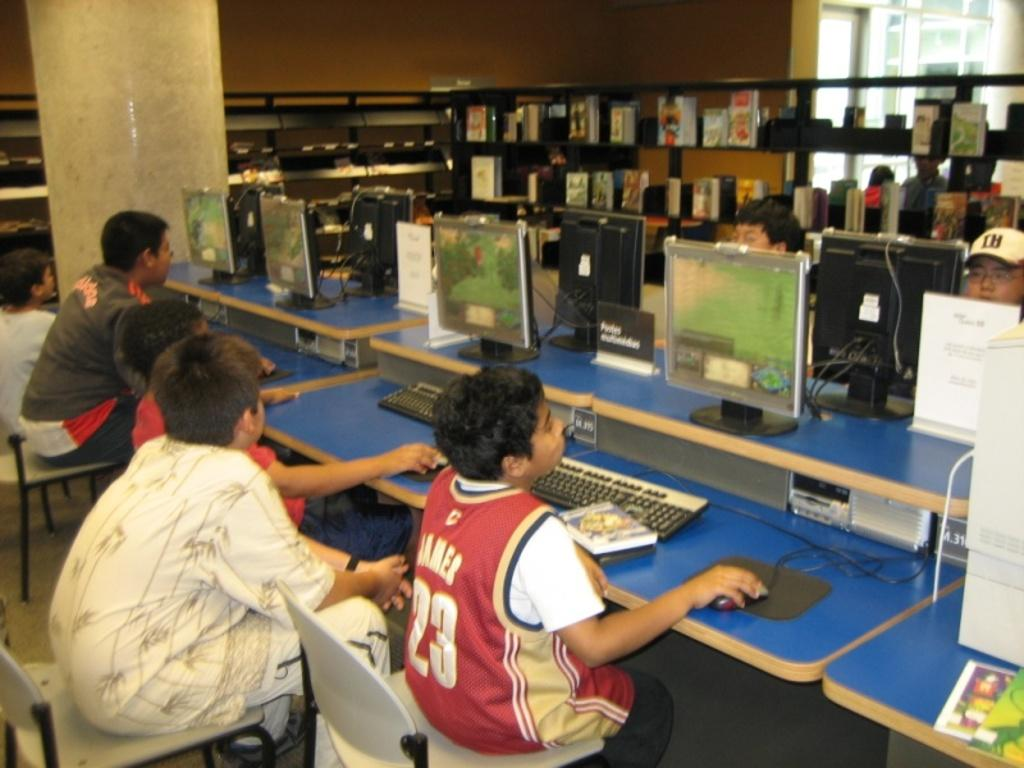<image>
Relay a brief, clear account of the picture shown. A boy wearing a James jersey sits with other children playing computer games. 